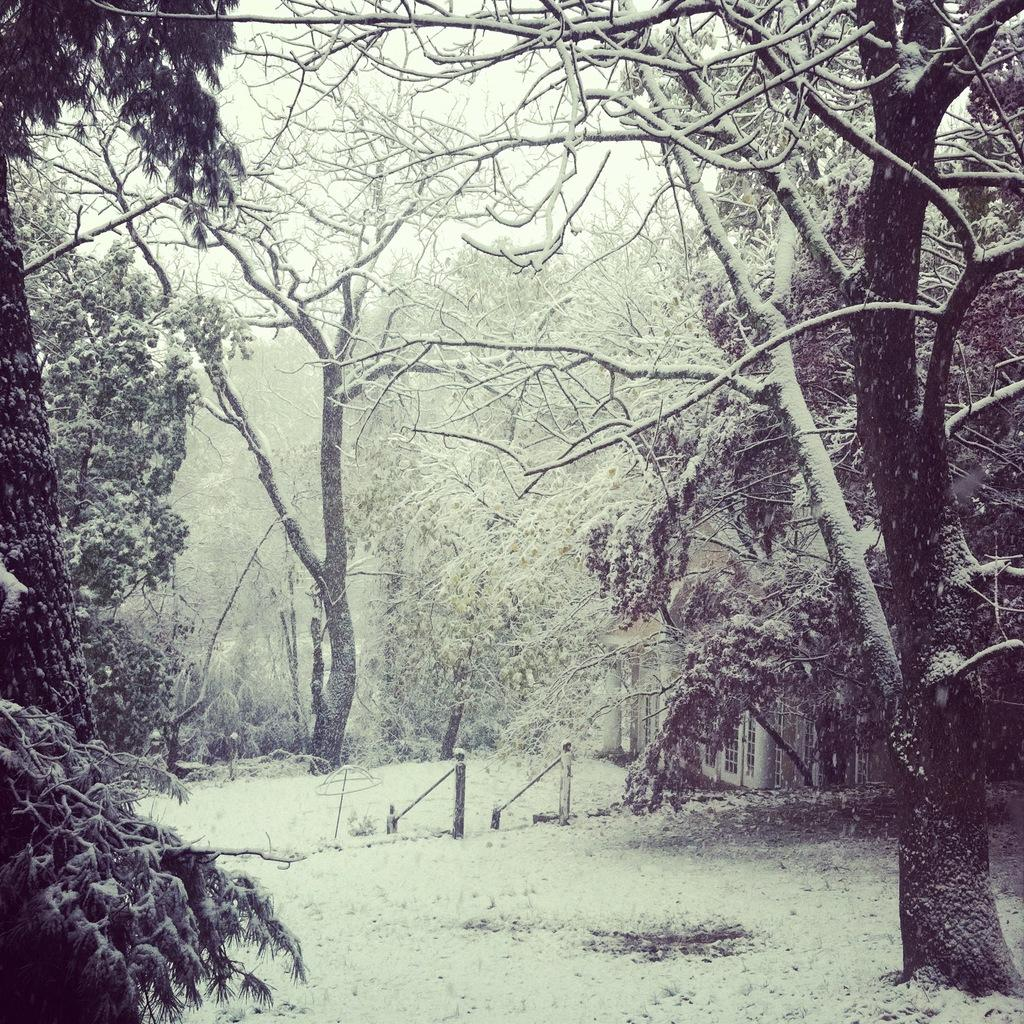What type of vegetation can be seen in the image? There are trees in the image. What is the ground covered with in the image? Snow is visible on the ground. Are the trees in the image also covered with snow? Yes, snow is also present on the trees. What color is the ink used to write on the fifth tree in the image? There is no ink or writing present on any of the trees in the image. 